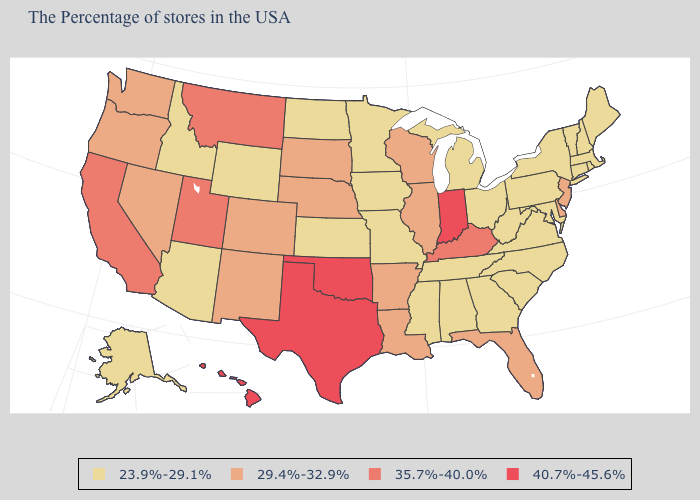What is the highest value in states that border Oregon?
Quick response, please. 35.7%-40.0%. Which states have the highest value in the USA?
Be succinct. Indiana, Oklahoma, Texas, Hawaii. Which states hav the highest value in the West?
Give a very brief answer. Hawaii. What is the value of Pennsylvania?
Be succinct. 23.9%-29.1%. Does Nebraska have the lowest value in the USA?
Quick response, please. No. Does Kentucky have the highest value in the South?
Quick response, please. No. Among the states that border Wyoming , does Colorado have the highest value?
Keep it brief. No. Name the states that have a value in the range 29.4%-32.9%?
Concise answer only. New Jersey, Delaware, Florida, Wisconsin, Illinois, Louisiana, Arkansas, Nebraska, South Dakota, Colorado, New Mexico, Nevada, Washington, Oregon. Among the states that border Arizona , does California have the highest value?
Short answer required. Yes. Does Hawaii have the highest value in the USA?
Quick response, please. Yes. Among the states that border Florida , which have the highest value?
Answer briefly. Georgia, Alabama. Name the states that have a value in the range 35.7%-40.0%?
Short answer required. Kentucky, Utah, Montana, California. Name the states that have a value in the range 35.7%-40.0%?
Be succinct. Kentucky, Utah, Montana, California. What is the highest value in the MidWest ?
Answer briefly. 40.7%-45.6%. Which states have the lowest value in the USA?
Keep it brief. Maine, Massachusetts, Rhode Island, New Hampshire, Vermont, Connecticut, New York, Maryland, Pennsylvania, Virginia, North Carolina, South Carolina, West Virginia, Ohio, Georgia, Michigan, Alabama, Tennessee, Mississippi, Missouri, Minnesota, Iowa, Kansas, North Dakota, Wyoming, Arizona, Idaho, Alaska. 